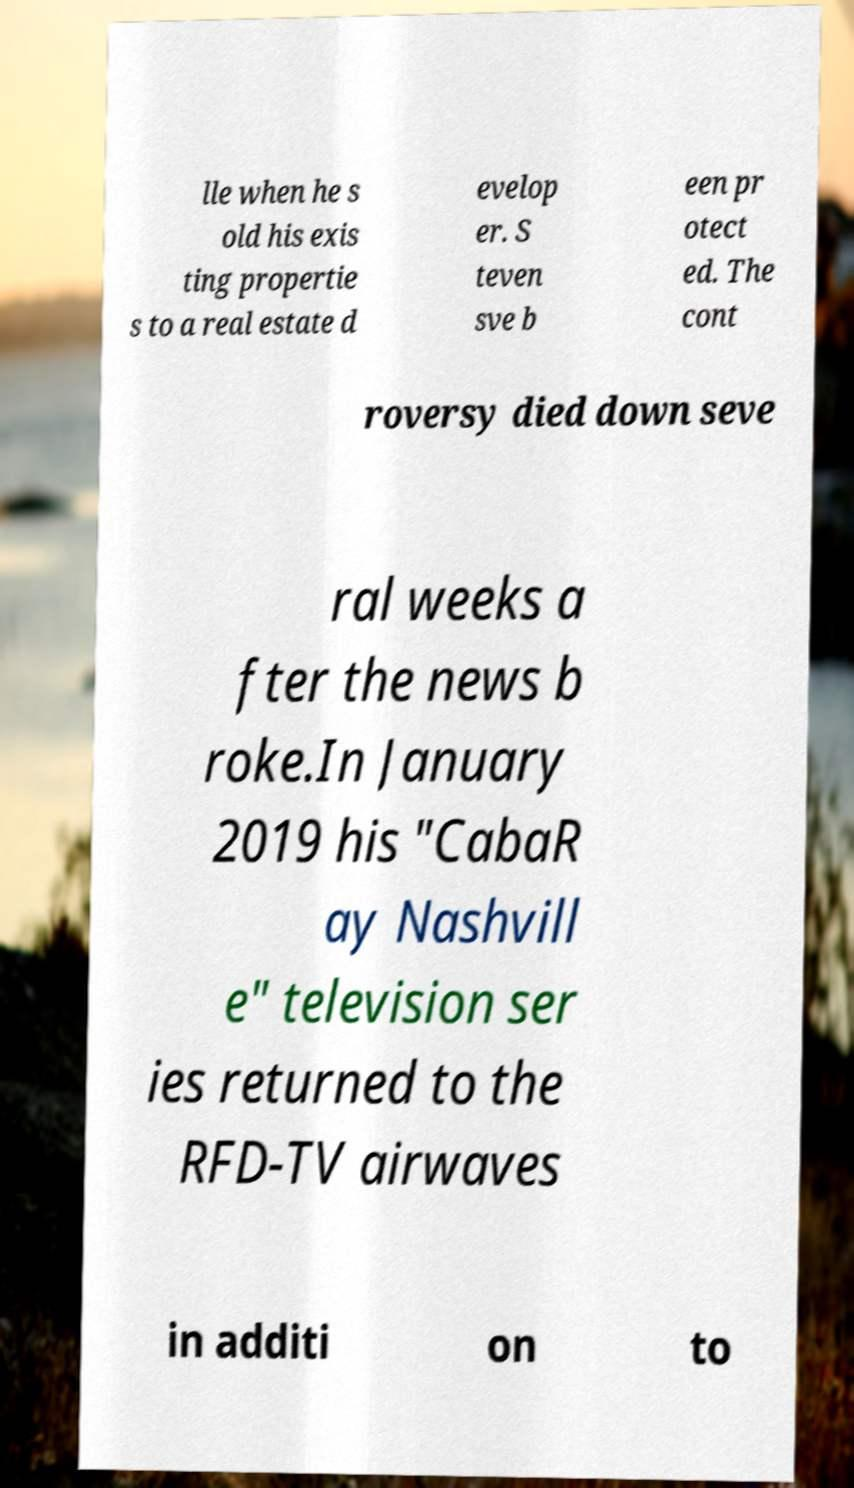Please identify and transcribe the text found in this image. lle when he s old his exis ting propertie s to a real estate d evelop er. S teven sve b een pr otect ed. The cont roversy died down seve ral weeks a fter the news b roke.In January 2019 his "CabaR ay Nashvill e" television ser ies returned to the RFD-TV airwaves in additi on to 